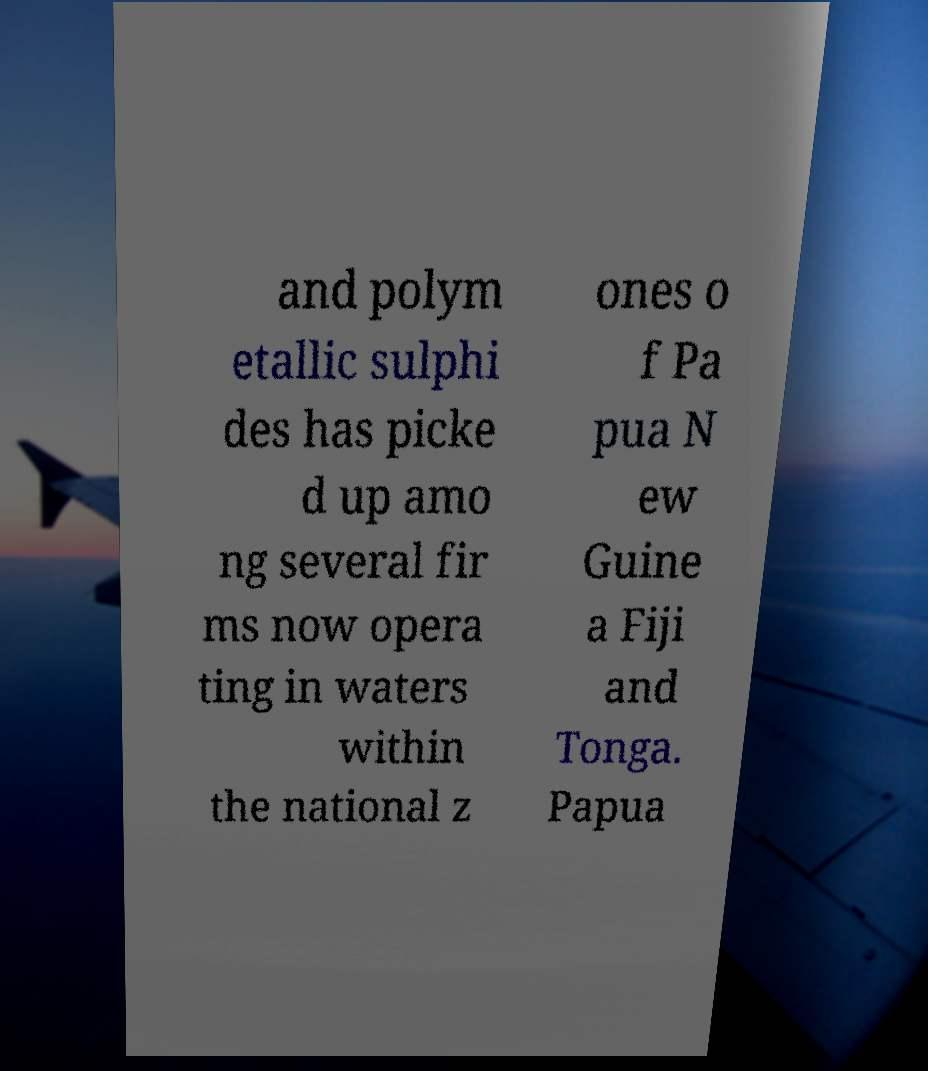I need the written content from this picture converted into text. Can you do that? and polym etallic sulphi des has picke d up amo ng several fir ms now opera ting in waters within the national z ones o f Pa pua N ew Guine a Fiji and Tonga. Papua 